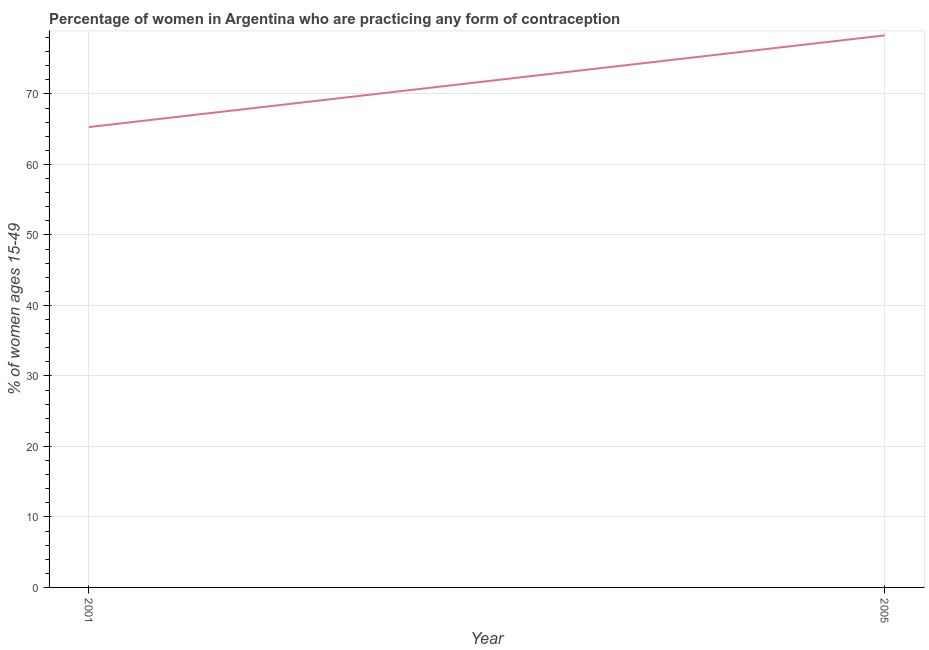What is the contraceptive prevalence in 2005?
Your answer should be compact. 78.3. Across all years, what is the maximum contraceptive prevalence?
Keep it short and to the point. 78.3. Across all years, what is the minimum contraceptive prevalence?
Offer a very short reply. 65.3. In which year was the contraceptive prevalence maximum?
Ensure brevity in your answer.  2005. What is the sum of the contraceptive prevalence?
Provide a short and direct response. 143.6. What is the average contraceptive prevalence per year?
Keep it short and to the point. 71.8. What is the median contraceptive prevalence?
Give a very brief answer. 71.8. What is the ratio of the contraceptive prevalence in 2001 to that in 2005?
Offer a very short reply. 0.83. Is the contraceptive prevalence in 2001 less than that in 2005?
Ensure brevity in your answer.  Yes. Does the contraceptive prevalence monotonically increase over the years?
Make the answer very short. Yes. What is the difference between two consecutive major ticks on the Y-axis?
Offer a terse response. 10. Are the values on the major ticks of Y-axis written in scientific E-notation?
Make the answer very short. No. Does the graph contain grids?
Your response must be concise. Yes. What is the title of the graph?
Provide a short and direct response. Percentage of women in Argentina who are practicing any form of contraception. What is the label or title of the X-axis?
Your response must be concise. Year. What is the label or title of the Y-axis?
Keep it short and to the point. % of women ages 15-49. What is the % of women ages 15-49 of 2001?
Offer a terse response. 65.3. What is the % of women ages 15-49 in 2005?
Offer a terse response. 78.3. What is the ratio of the % of women ages 15-49 in 2001 to that in 2005?
Your answer should be compact. 0.83. 